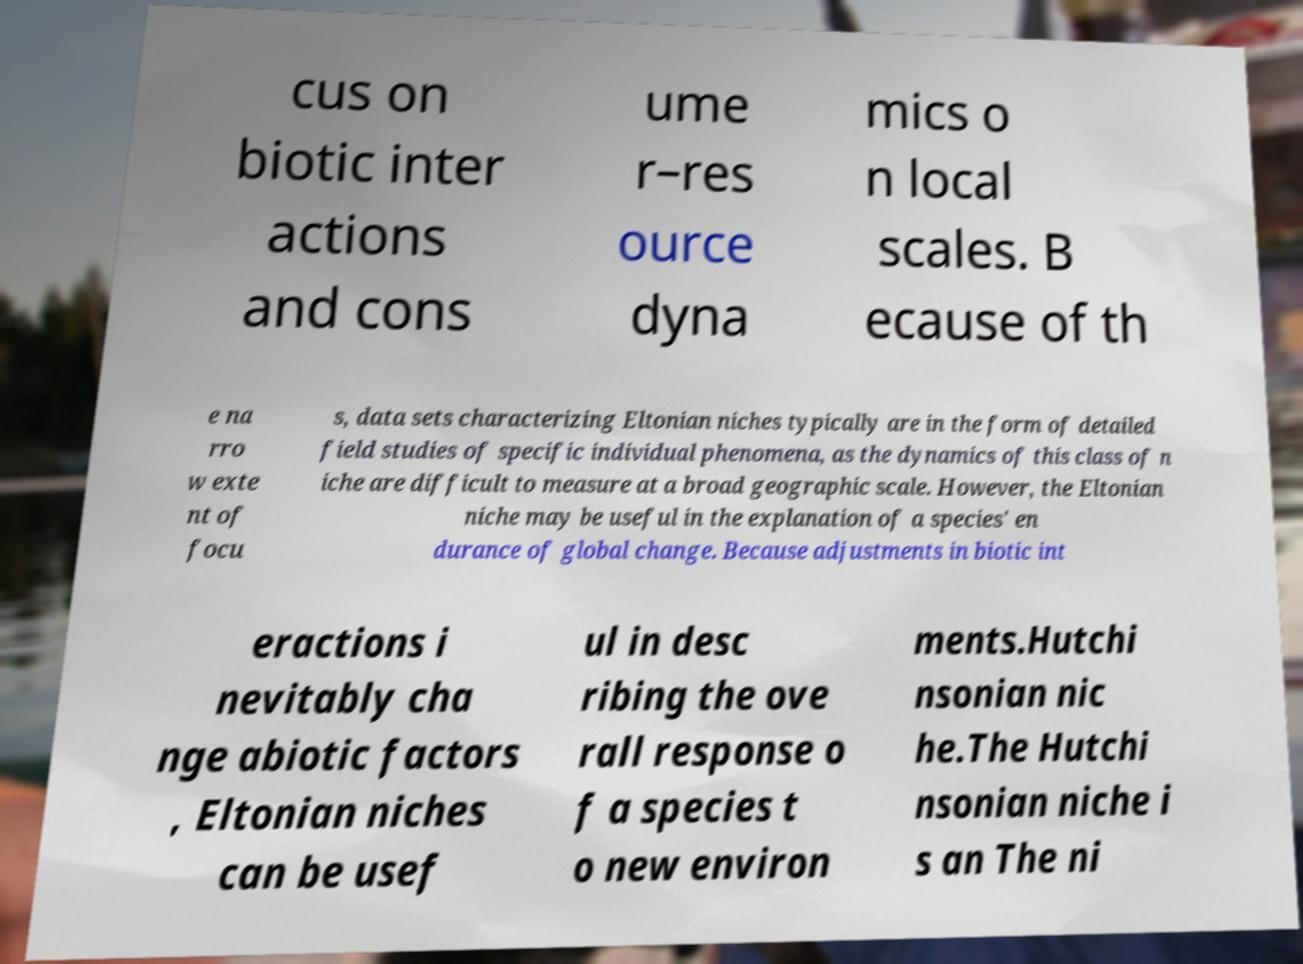Please read and relay the text visible in this image. What does it say? cus on biotic inter actions and cons ume r–res ource dyna mics o n local scales. B ecause of th e na rro w exte nt of focu s, data sets characterizing Eltonian niches typically are in the form of detailed field studies of specific individual phenomena, as the dynamics of this class of n iche are difficult to measure at a broad geographic scale. However, the Eltonian niche may be useful in the explanation of a species' en durance of global change. Because adjustments in biotic int eractions i nevitably cha nge abiotic factors , Eltonian niches can be usef ul in desc ribing the ove rall response o f a species t o new environ ments.Hutchi nsonian nic he.The Hutchi nsonian niche i s an The ni 